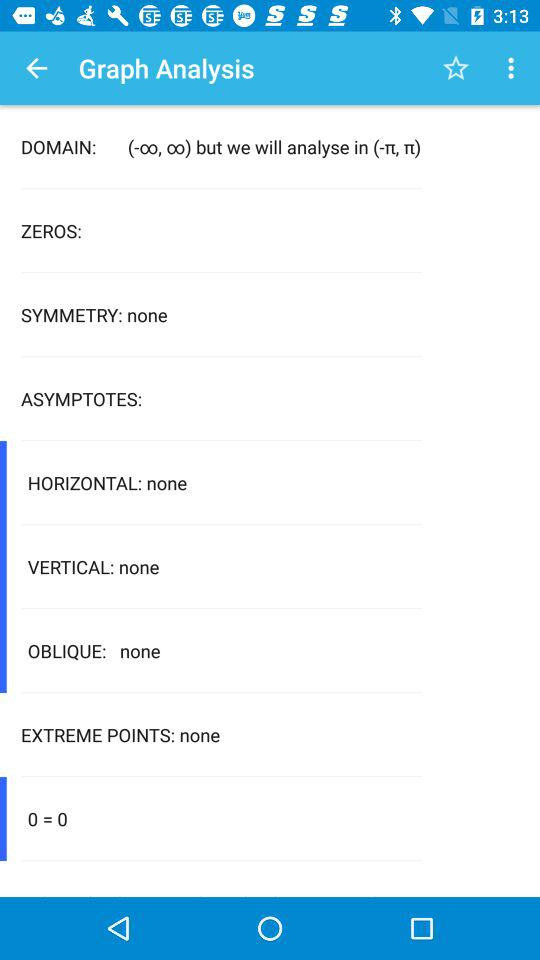What is mentioned in "SYMMETRY"? In "SYMMETRY", "none" is mentioned. 